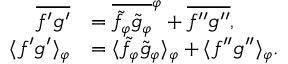Convert formula to latex. <formula><loc_0><loc_0><loc_500><loc_500>\begin{array} { r l } { \overline { { f ^ { \prime } g ^ { \prime } } } } & { = \overline { { \tilde { f } _ { \varphi } \tilde { g } _ { \varphi } } } ^ { \varphi } + \overline { { f ^ { \prime \prime } g ^ { \prime \prime } } } , } \\ { \langle { f ^ { \prime } g ^ { \prime } } \rangle _ { \varphi } } & { = \langle { \tilde { f } _ { \varphi } \tilde { g } _ { \varphi } } \rangle _ { \varphi } + \langle { f ^ { \prime \prime } g ^ { \prime \prime } } \rangle _ { \varphi } . } \end{array}</formula> 